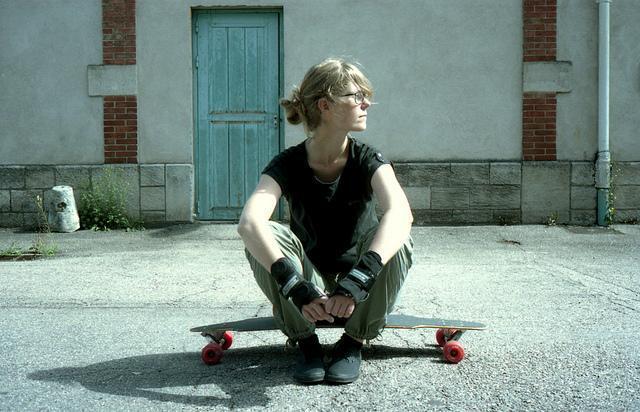How many people are there?
Give a very brief answer. 1. How many skateboards are there?
Give a very brief answer. 1. How many cars are driving in the opposite direction of the street car?
Give a very brief answer. 0. 